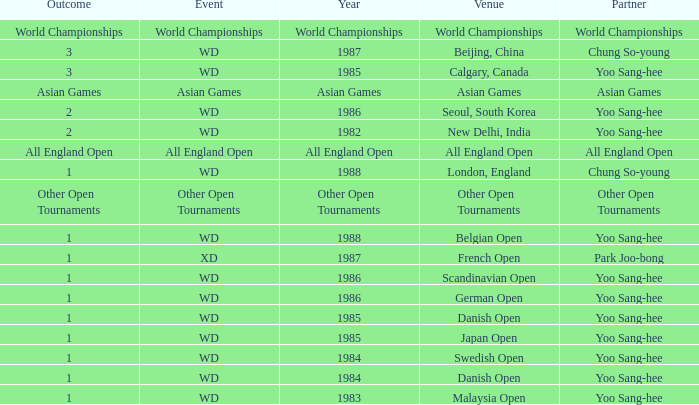What is the companion during the asian games year? Asian Games. 